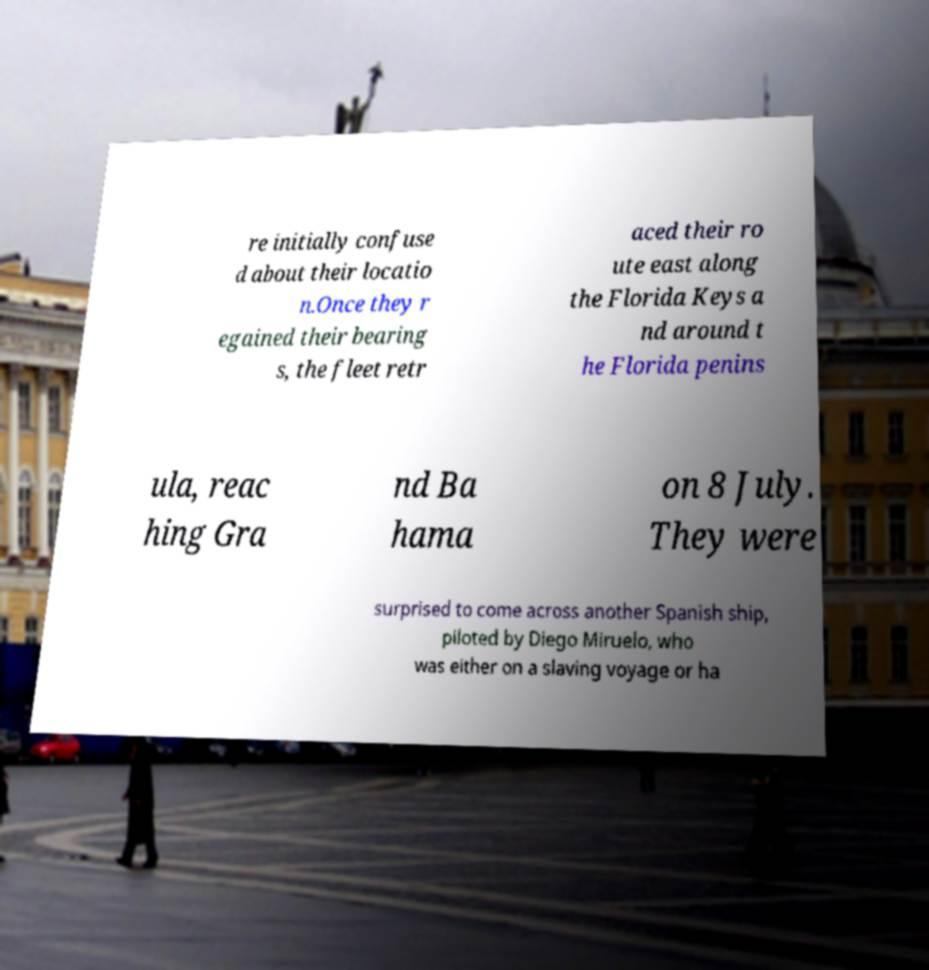What messages or text are displayed in this image? I need them in a readable, typed format. re initially confuse d about their locatio n.Once they r egained their bearing s, the fleet retr aced their ro ute east along the Florida Keys a nd around t he Florida penins ula, reac hing Gra nd Ba hama on 8 July. They were surprised to come across another Spanish ship, piloted by Diego Miruelo, who was either on a slaving voyage or ha 